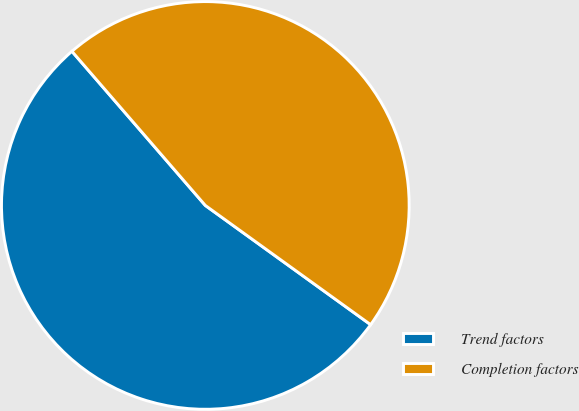Convert chart. <chart><loc_0><loc_0><loc_500><loc_500><pie_chart><fcel>Trend factors<fcel>Completion factors<nl><fcel>53.7%<fcel>46.3%<nl></chart> 